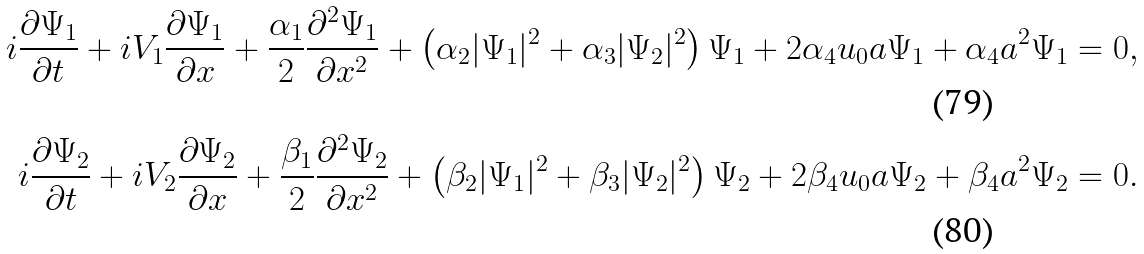<formula> <loc_0><loc_0><loc_500><loc_500>i \frac { \partial \Psi _ { 1 } } { \partial t } + i V _ { 1 } \frac { \partial \Psi _ { 1 } } { \partial x } + \frac { \alpha _ { 1 } } { 2 } \frac { \partial ^ { 2 } \Psi _ { 1 } } { \partial x ^ { 2 } } + \left ( \alpha _ { 2 } | \Psi _ { 1 } | ^ { 2 } + \alpha _ { 3 } | \Psi _ { 2 } | ^ { 2 } \right ) \Psi _ { 1 } + 2 \alpha _ { 4 } u _ { 0 } a \Psi _ { 1 } + \alpha _ { 4 } a ^ { 2 } \Psi _ { 1 } = 0 , \\ i \frac { \partial \Psi _ { 2 } } { \partial t } + i V _ { 2 } \frac { \partial \Psi _ { 2 } } { \partial x } + \frac { \beta _ { 1 } } { 2 } \frac { \partial ^ { 2 } \Psi _ { 2 } } { \partial x ^ { 2 } } + \left ( \beta _ { 2 } | \Psi _ { 1 } | ^ { 2 } + \beta _ { 3 } | \Psi _ { 2 } | ^ { 2 } \right ) \Psi _ { 2 } + 2 \beta _ { 4 } u _ { 0 } a \Psi _ { 2 } + \beta _ { 4 } a ^ { 2 } \Psi _ { 2 } = 0 .</formula> 